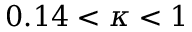<formula> <loc_0><loc_0><loc_500><loc_500>0 . 1 4 < \kappa < 1</formula> 